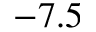Convert formula to latex. <formula><loc_0><loc_0><loc_500><loc_500>- 7 . 5</formula> 